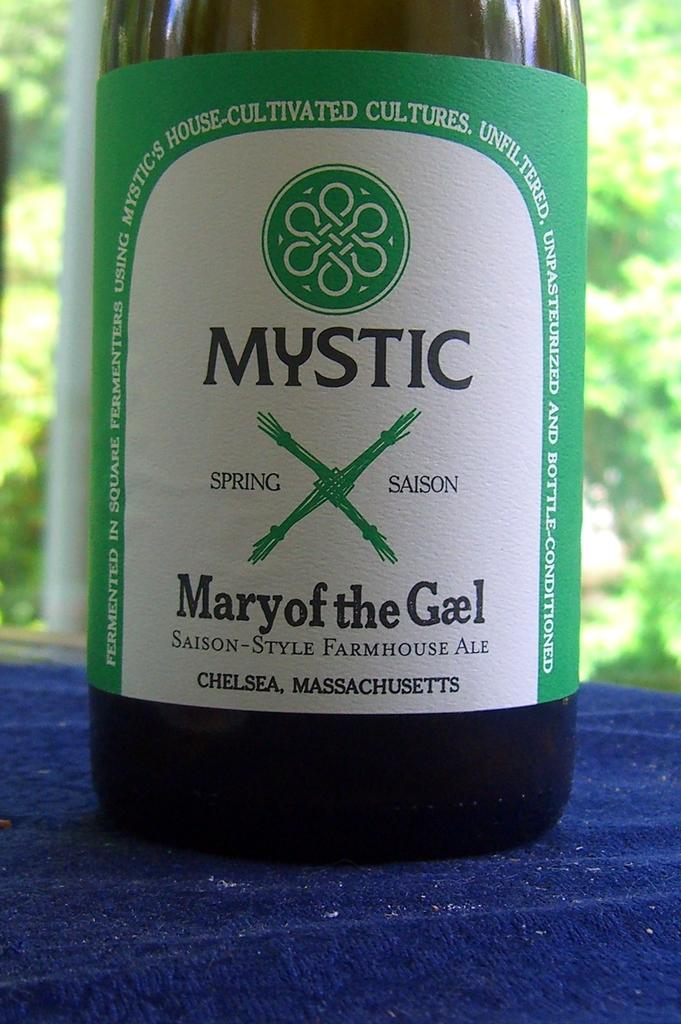<image>
Offer a succinct explanation of the picture presented. A bottle of ale, labelled Mystic Mary of the Gael, is made in Chelsea, Massachusetts. 